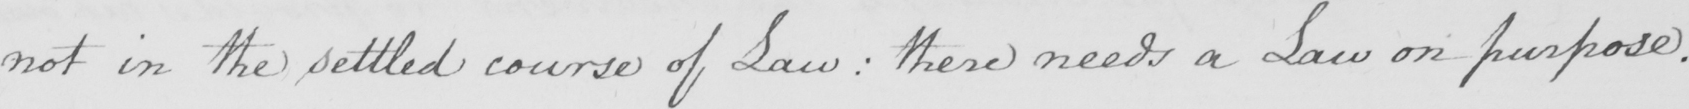Can you tell me what this handwritten text says? not in the settled course of Law :  there needs a Law on purpose . 